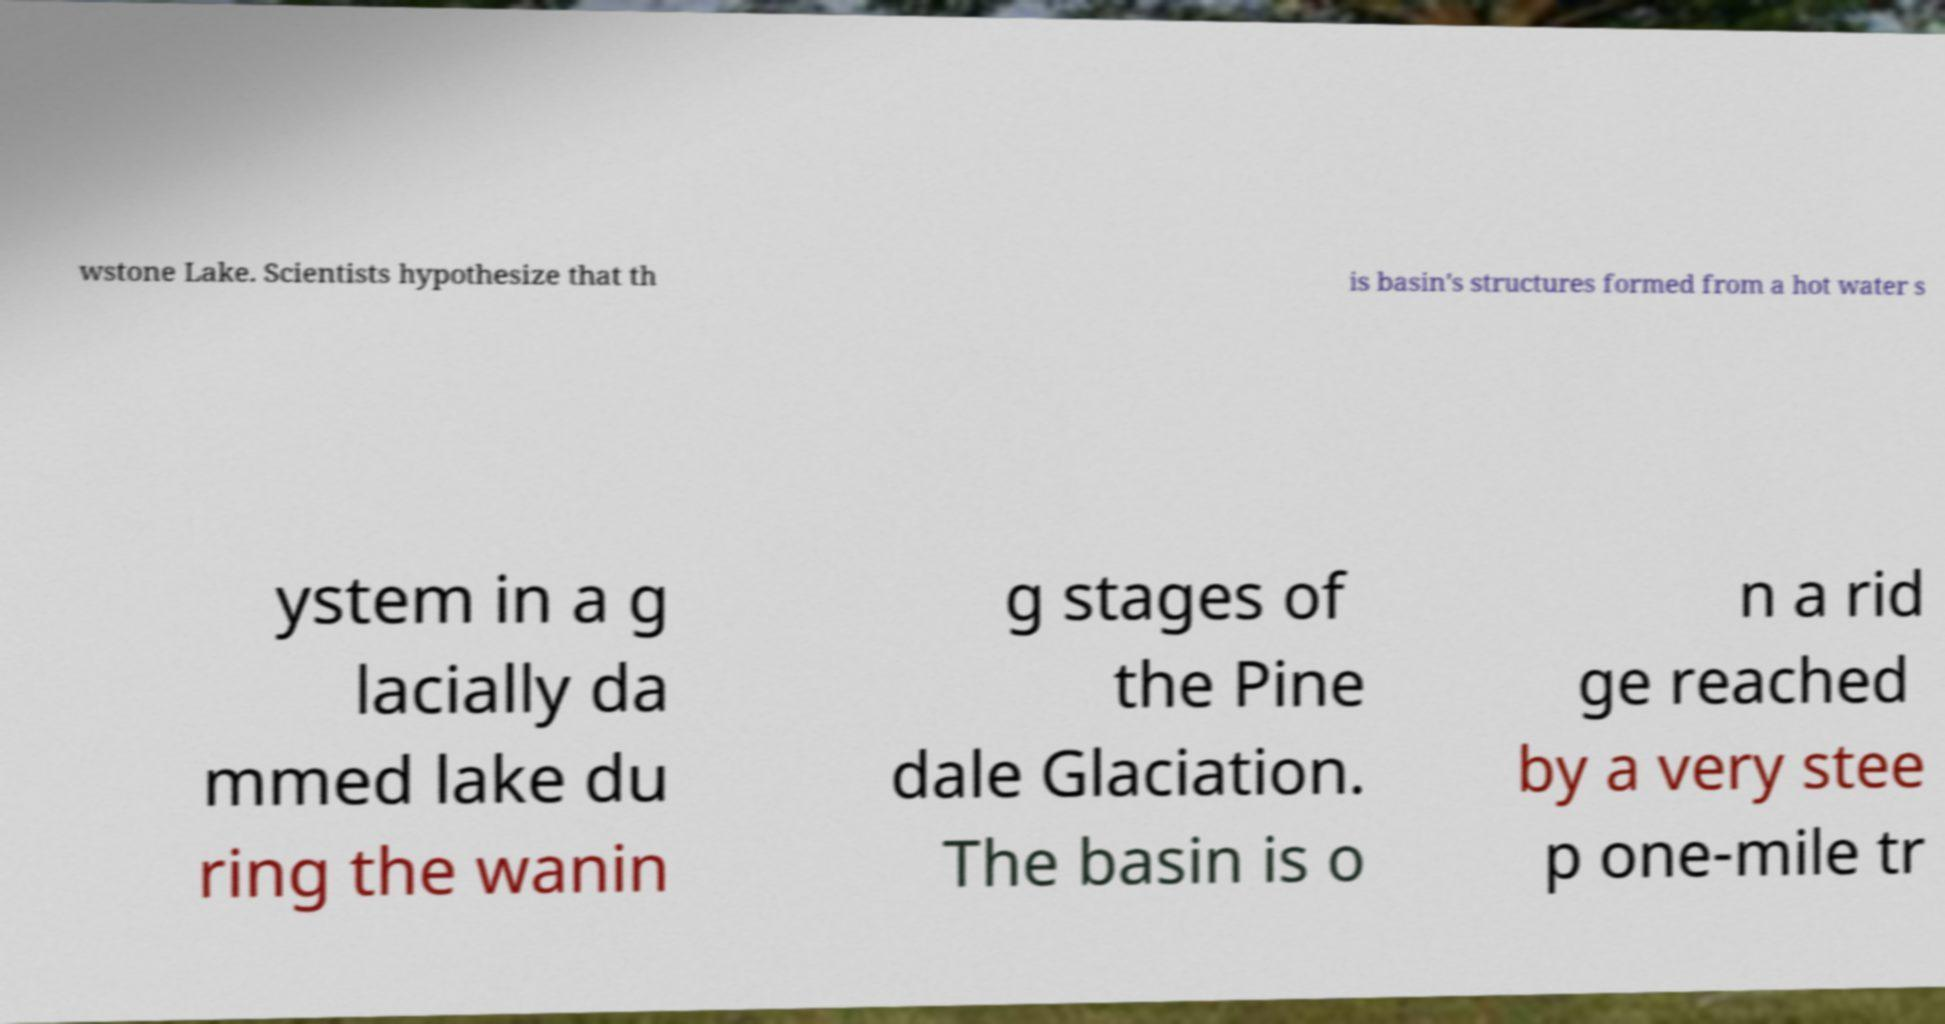Could you assist in decoding the text presented in this image and type it out clearly? wstone Lake. Scientists hypothesize that th is basin's structures formed from a hot water s ystem in a g lacially da mmed lake du ring the wanin g stages of the Pine dale Glaciation. The basin is o n a rid ge reached by a very stee p one-mile tr 